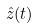<formula> <loc_0><loc_0><loc_500><loc_500>\hat { z } ( t )</formula> 